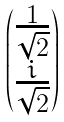Convert formula to latex. <formula><loc_0><loc_0><loc_500><loc_500>\begin{pmatrix} \frac { 1 } { \sqrt { 2 } } \\ \frac { i } { \sqrt { 2 } } \end{pmatrix}</formula> 